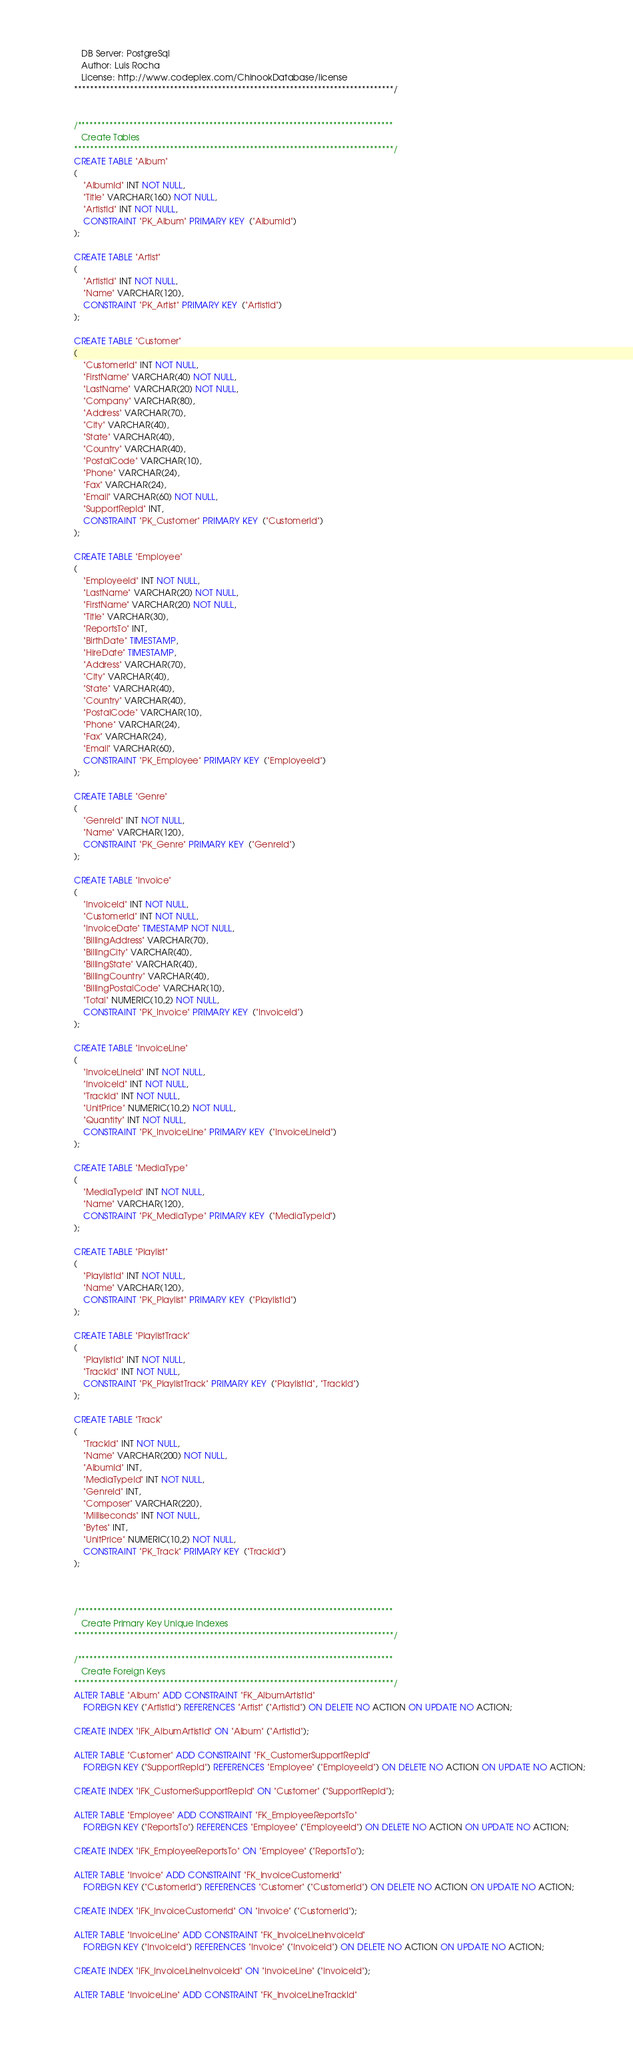<code> <loc_0><loc_0><loc_500><loc_500><_SQL_>   DB Server: PostgreSql
   Author: Luis Rocha
   License: http://www.codeplex.com/ChinookDatabase/license
********************************************************************************/


/*******************************************************************************
   Create Tables
********************************************************************************/
CREATE TABLE "Album"
(
    "AlbumId" INT NOT NULL,
    "Title" VARCHAR(160) NOT NULL,
    "ArtistId" INT NOT NULL,
    CONSTRAINT "PK_Album" PRIMARY KEY  ("AlbumId")
);

CREATE TABLE "Artist"
(
    "ArtistId" INT NOT NULL,
    "Name" VARCHAR(120),
    CONSTRAINT "PK_Artist" PRIMARY KEY  ("ArtistId")
);

CREATE TABLE "Customer"
(
    "CustomerId" INT NOT NULL,
    "FirstName" VARCHAR(40) NOT NULL,
    "LastName" VARCHAR(20) NOT NULL,
    "Company" VARCHAR(80),
    "Address" VARCHAR(70),
    "City" VARCHAR(40),
    "State" VARCHAR(40),
    "Country" VARCHAR(40),
    "PostalCode" VARCHAR(10),
    "Phone" VARCHAR(24),
    "Fax" VARCHAR(24),
    "Email" VARCHAR(60) NOT NULL,
    "SupportRepId" INT,
    CONSTRAINT "PK_Customer" PRIMARY KEY  ("CustomerId")
);

CREATE TABLE "Employee"
(
    "EmployeeId" INT NOT NULL,
    "LastName" VARCHAR(20) NOT NULL,
    "FirstName" VARCHAR(20) NOT NULL,
    "Title" VARCHAR(30),
    "ReportsTo" INT,
    "BirthDate" TIMESTAMP,
    "HireDate" TIMESTAMP,
    "Address" VARCHAR(70),
    "City" VARCHAR(40),
    "State" VARCHAR(40),
    "Country" VARCHAR(40),
    "PostalCode" VARCHAR(10),
    "Phone" VARCHAR(24),
    "Fax" VARCHAR(24),
    "Email" VARCHAR(60),
    CONSTRAINT "PK_Employee" PRIMARY KEY  ("EmployeeId")
);

CREATE TABLE "Genre"
(
    "GenreId" INT NOT NULL,
    "Name" VARCHAR(120),
    CONSTRAINT "PK_Genre" PRIMARY KEY  ("GenreId")
);

CREATE TABLE "Invoice"
(
    "InvoiceId" INT NOT NULL,
    "CustomerId" INT NOT NULL,
    "InvoiceDate" TIMESTAMP NOT NULL,
    "BillingAddress" VARCHAR(70),
    "BillingCity" VARCHAR(40),
    "BillingState" VARCHAR(40),
    "BillingCountry" VARCHAR(40),
    "BillingPostalCode" VARCHAR(10),
    "Total" NUMERIC(10,2) NOT NULL,
    CONSTRAINT "PK_Invoice" PRIMARY KEY  ("InvoiceId")
);

CREATE TABLE "InvoiceLine"
(
    "InvoiceLineId" INT NOT NULL,
    "InvoiceId" INT NOT NULL,
    "TrackId" INT NOT NULL,
    "UnitPrice" NUMERIC(10,2) NOT NULL,
    "Quantity" INT NOT NULL,
    CONSTRAINT "PK_InvoiceLine" PRIMARY KEY  ("InvoiceLineId")
);

CREATE TABLE "MediaType"
(
    "MediaTypeId" INT NOT NULL,
    "Name" VARCHAR(120),
    CONSTRAINT "PK_MediaType" PRIMARY KEY  ("MediaTypeId")
);

CREATE TABLE "Playlist"
(
    "PlaylistId" INT NOT NULL,
    "Name" VARCHAR(120),
    CONSTRAINT "PK_Playlist" PRIMARY KEY  ("PlaylistId")
);

CREATE TABLE "PlaylistTrack"
(
    "PlaylistId" INT NOT NULL,
    "TrackId" INT NOT NULL,
    CONSTRAINT "PK_PlaylistTrack" PRIMARY KEY  ("PlaylistId", "TrackId")
);

CREATE TABLE "Track"
(
    "TrackId" INT NOT NULL,
    "Name" VARCHAR(200) NOT NULL,
    "AlbumId" INT,
    "MediaTypeId" INT NOT NULL,
    "GenreId" INT,
    "Composer" VARCHAR(220),
    "Milliseconds" INT NOT NULL,
    "Bytes" INT,
    "UnitPrice" NUMERIC(10,2) NOT NULL,
    CONSTRAINT "PK_Track" PRIMARY KEY  ("TrackId")
);



/*******************************************************************************
   Create Primary Key Unique Indexes
********************************************************************************/

/*******************************************************************************
   Create Foreign Keys
********************************************************************************/
ALTER TABLE "Album" ADD CONSTRAINT "FK_AlbumArtistId"
    FOREIGN KEY ("ArtistId") REFERENCES "Artist" ("ArtistId") ON DELETE NO ACTION ON UPDATE NO ACTION;

CREATE INDEX "IFK_AlbumArtistId" ON "Album" ("ArtistId");

ALTER TABLE "Customer" ADD CONSTRAINT "FK_CustomerSupportRepId"
    FOREIGN KEY ("SupportRepId") REFERENCES "Employee" ("EmployeeId") ON DELETE NO ACTION ON UPDATE NO ACTION;

CREATE INDEX "IFK_CustomerSupportRepId" ON "Customer" ("SupportRepId");

ALTER TABLE "Employee" ADD CONSTRAINT "FK_EmployeeReportsTo"
    FOREIGN KEY ("ReportsTo") REFERENCES "Employee" ("EmployeeId") ON DELETE NO ACTION ON UPDATE NO ACTION;

CREATE INDEX "IFK_EmployeeReportsTo" ON "Employee" ("ReportsTo");

ALTER TABLE "Invoice" ADD CONSTRAINT "FK_InvoiceCustomerId"
    FOREIGN KEY ("CustomerId") REFERENCES "Customer" ("CustomerId") ON DELETE NO ACTION ON UPDATE NO ACTION;

CREATE INDEX "IFK_InvoiceCustomerId" ON "Invoice" ("CustomerId");

ALTER TABLE "InvoiceLine" ADD CONSTRAINT "FK_InvoiceLineInvoiceId"
    FOREIGN KEY ("InvoiceId") REFERENCES "Invoice" ("InvoiceId") ON DELETE NO ACTION ON UPDATE NO ACTION;

CREATE INDEX "IFK_InvoiceLineInvoiceId" ON "InvoiceLine" ("InvoiceId");

ALTER TABLE "InvoiceLine" ADD CONSTRAINT "FK_InvoiceLineTrackId"</code> 